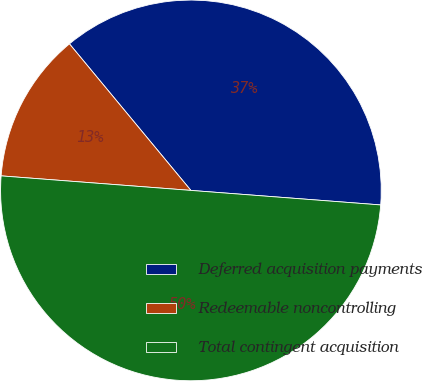Convert chart to OTSL. <chart><loc_0><loc_0><loc_500><loc_500><pie_chart><fcel>Deferred acquisition payments<fcel>Redeemable noncontrolling<fcel>Total contingent acquisition<nl><fcel>37.23%<fcel>12.77%<fcel>50.0%<nl></chart> 